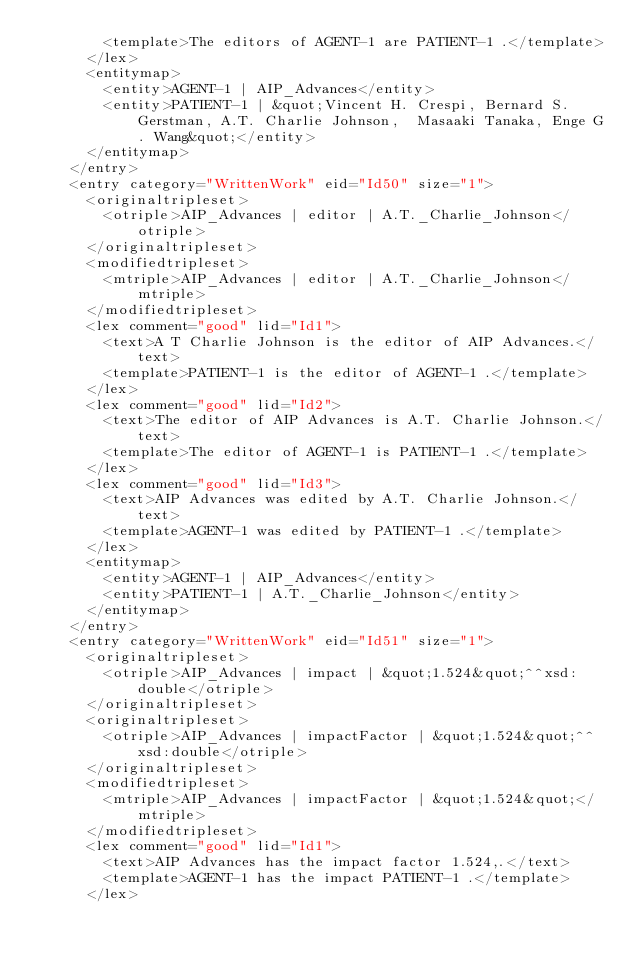Convert code to text. <code><loc_0><loc_0><loc_500><loc_500><_XML_>				<template>The editors of AGENT-1 are PATIENT-1 .</template>
			</lex>
			<entitymap>
				<entity>AGENT-1 | AIP_Advances</entity>
				<entity>PATIENT-1 | &quot;Vincent H. Crespi, Bernard S. Gerstman, A.T. Charlie Johnson,  Masaaki Tanaka, Enge G. Wang&quot;</entity>
			</entitymap>
		</entry>
		<entry category="WrittenWork" eid="Id50" size="1">
			<originaltripleset>
				<otriple>AIP_Advances | editor | A.T._Charlie_Johnson</otriple>
			</originaltripleset>
			<modifiedtripleset>
				<mtriple>AIP_Advances | editor | A.T._Charlie_Johnson</mtriple>
			</modifiedtripleset>
			<lex comment="good" lid="Id1">
				<text>A T Charlie Johnson is the editor of AIP Advances.</text>
				<template>PATIENT-1 is the editor of AGENT-1 .</template>
			</lex>
			<lex comment="good" lid="Id2">
				<text>The editor of AIP Advances is A.T. Charlie Johnson.</text>
				<template>The editor of AGENT-1 is PATIENT-1 .</template>
			</lex>
			<lex comment="good" lid="Id3">
				<text>AIP Advances was edited by A.T. Charlie Johnson.</text>
				<template>AGENT-1 was edited by PATIENT-1 .</template>
			</lex>
			<entitymap>
				<entity>AGENT-1 | AIP_Advances</entity>
				<entity>PATIENT-1 | A.T._Charlie_Johnson</entity>
			</entitymap>
		</entry>
		<entry category="WrittenWork" eid="Id51" size="1">
			<originaltripleset>
				<otriple>AIP_Advances | impact | &quot;1.524&quot;^^xsd:double</otriple>
			</originaltripleset>
			<originaltripleset>
				<otriple>AIP_Advances | impactFactor | &quot;1.524&quot;^^xsd:double</otriple>
			</originaltripleset>
			<modifiedtripleset>
				<mtriple>AIP_Advances | impactFactor | &quot;1.524&quot;</mtriple>
			</modifiedtripleset>
			<lex comment="good" lid="Id1">
				<text>AIP Advances has the impact factor 1.524,.</text>
				<template>AGENT-1 has the impact PATIENT-1 .</template>
			</lex></code> 